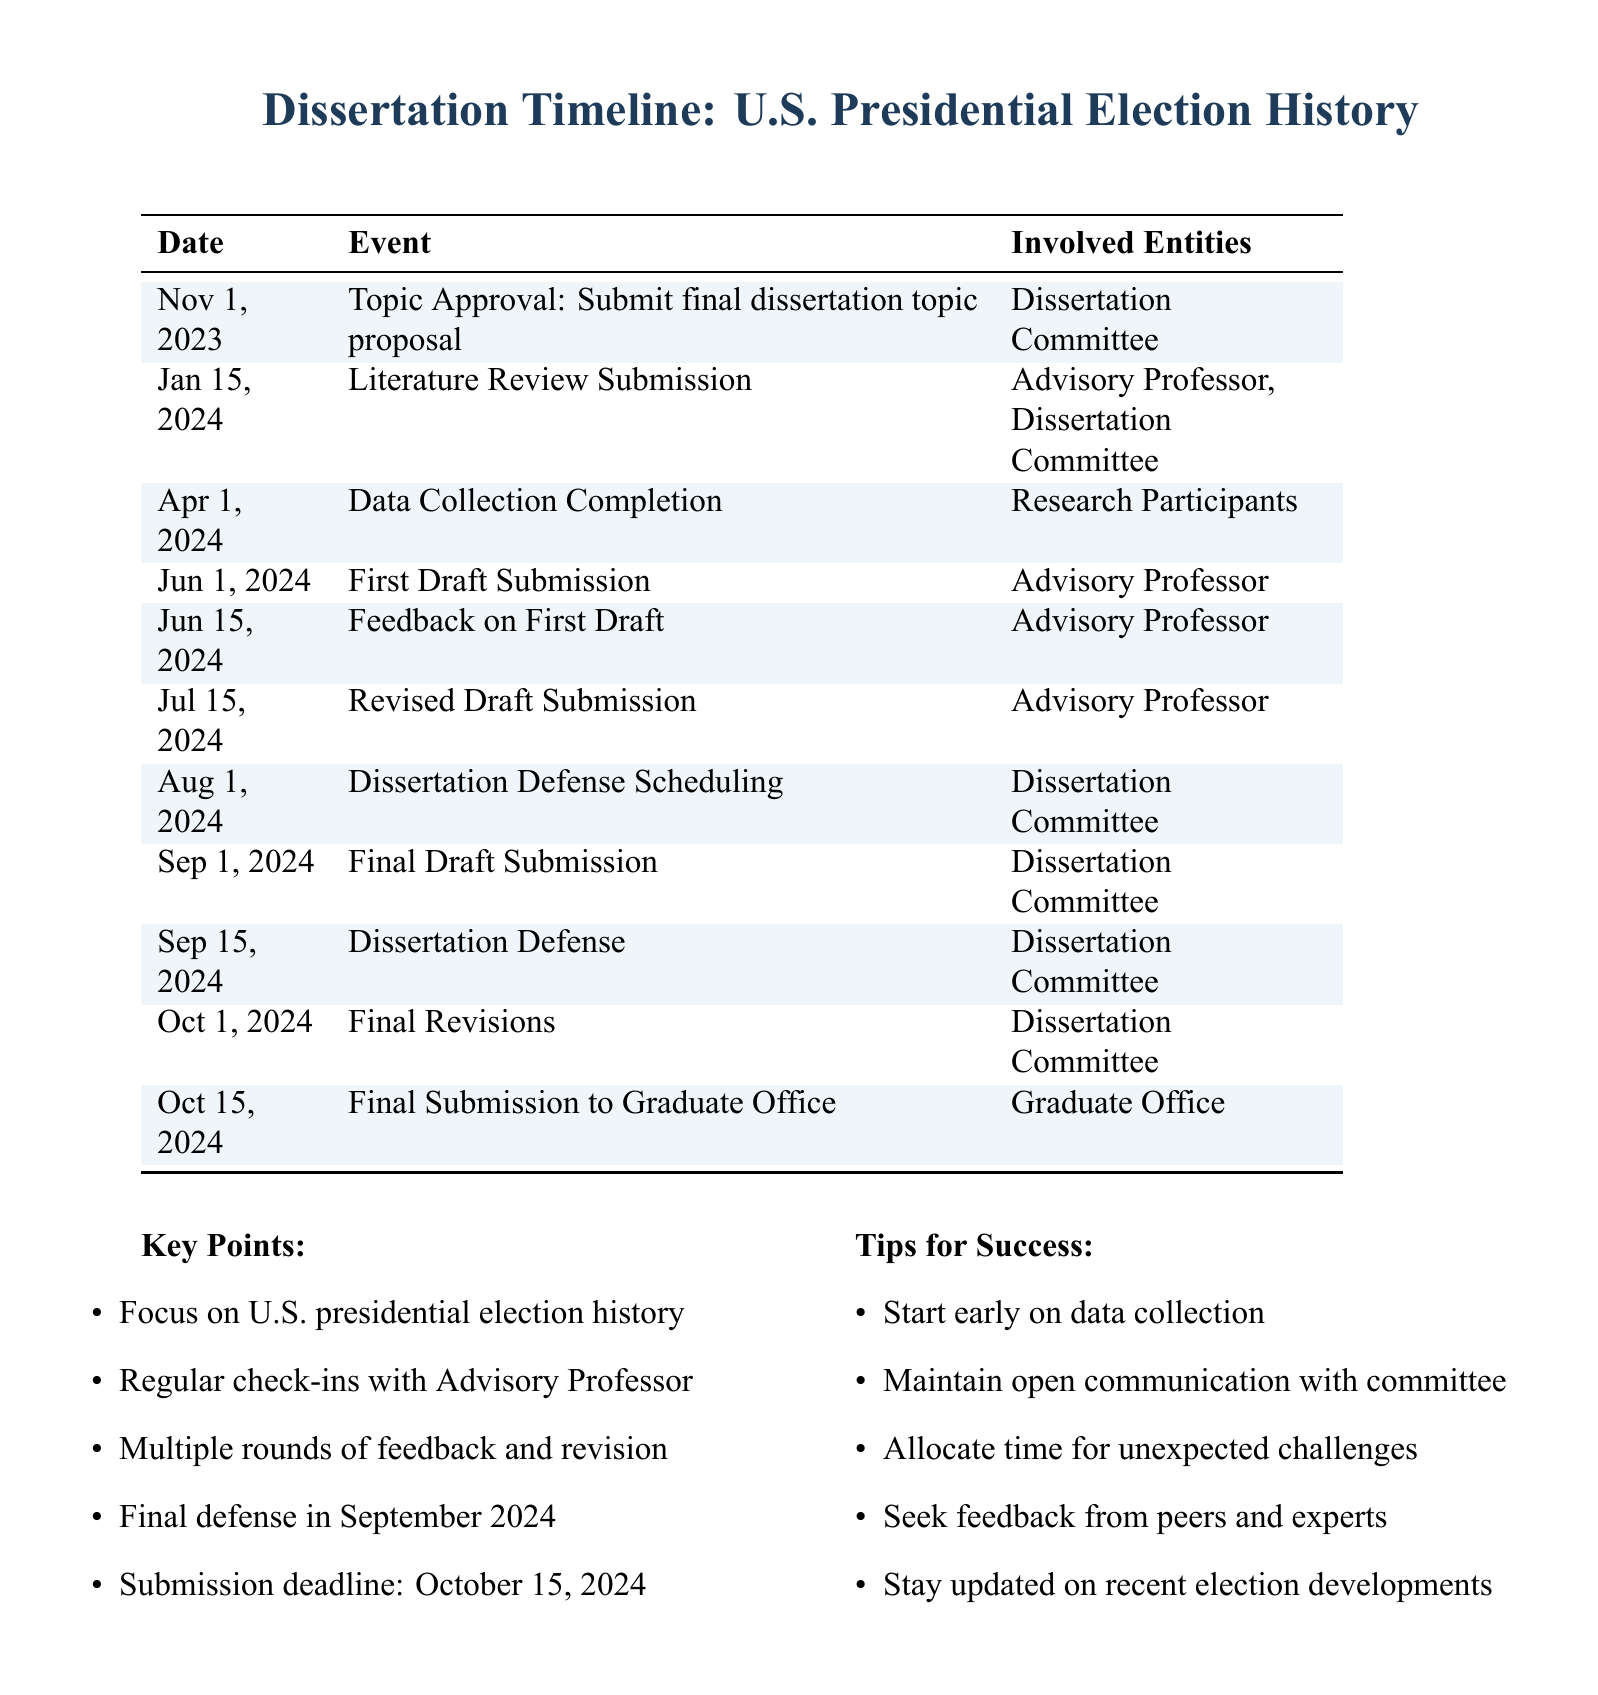What is the final submission deadline? The final submission deadline is specifically mentioned in the document as October 15, 2024.
Answer: October 15, 2024 Who needs to approve the dissertation topic proposal? The document states that the Dissertation Committee is responsible for approving the final dissertation topic proposal.
Answer: Dissertation Committee When is the feedback on the first draft due? According to the document, feedback on the first draft is due on June 15, 2024.
Answer: June 15, 2024 How many weeks are there between the first draft submission and the final draft submission? The document shows that the first draft submission is on June 1, 2024, and the final draft submission is on September 1, 2024, which is approximately 13 weeks apart.
Answer: 13 weeks What event occurs on April 1, 2024? The event listed for April 1, 2024, is the completion of data collection, which is crucial for the dissertation process.
Answer: Data Collection Completion What is the purpose of the key points listed in the document? The key points highlight important aspects that the student should focus on during their dissertation journey, indicating the process and critical timelines involved.
Answer: Focus areas for dissertation Which entity requires the final draft submission? The document specifies that the Dissertation Committee is responsible for receiving the final draft submission.
Answer: Dissertation Committee 